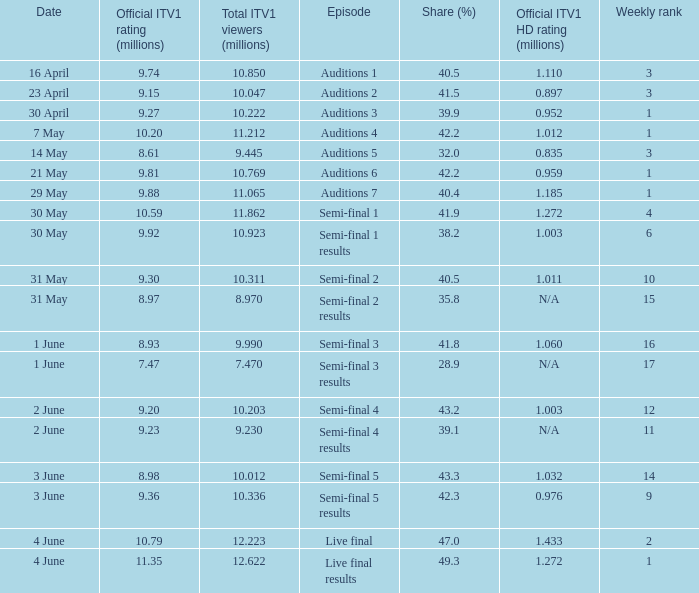When was the episode that had a share (%) of 41.5? 23 April. 